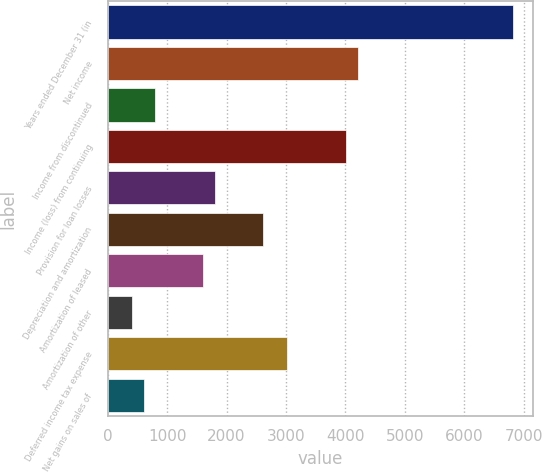<chart> <loc_0><loc_0><loc_500><loc_500><bar_chart><fcel>Years ended December 31 (in<fcel>Net income<fcel>Income from discontinued<fcel>Income (loss) from continuing<fcel>Provision for loan losses<fcel>Depreciation and amortization<fcel>Amortization of leased<fcel>Amortization of other<fcel>Deferred income tax expense<fcel>Net gains on sales of<nl><fcel>6819.44<fcel>4212.16<fcel>802.64<fcel>4011.6<fcel>1805.44<fcel>2607.68<fcel>1604.88<fcel>401.52<fcel>3008.8<fcel>602.08<nl></chart> 